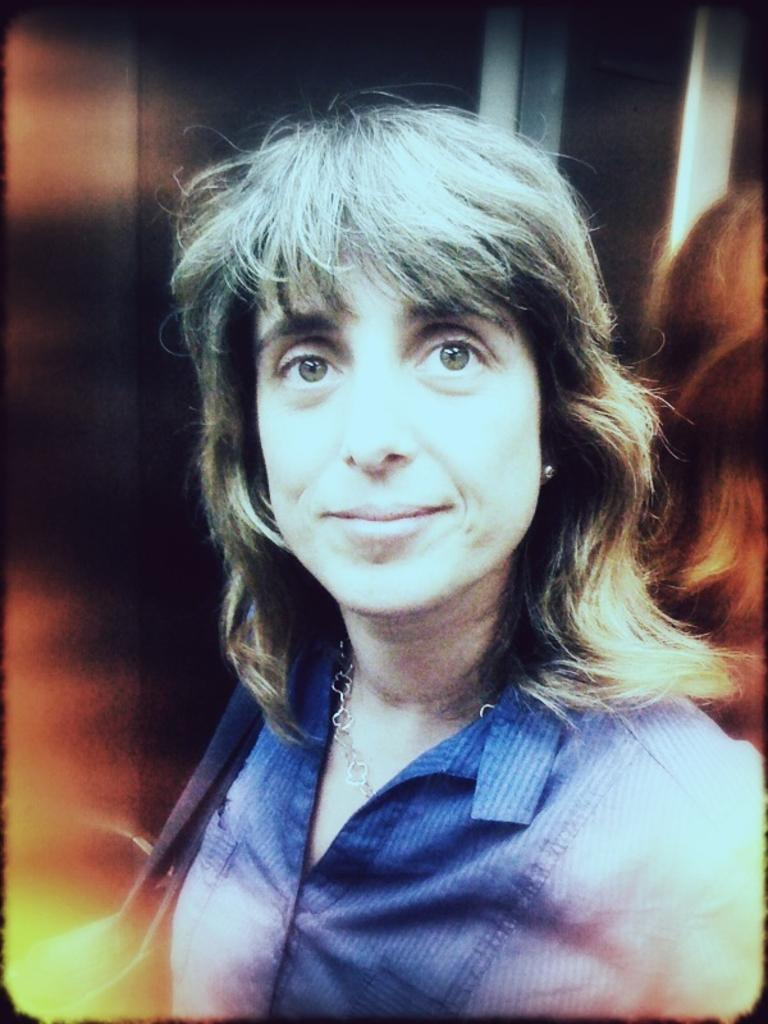Who or what is the main subject in the image? There is a person in the image. What is the person wearing? The person is wearing a dress. Can you describe the background of the image? The background of the image is blurred. How many dogs can be seen running in the image? There are no dogs present in the image, and they are not running. What type of drink is the person holding in the image? There is no drink visible in the image. 